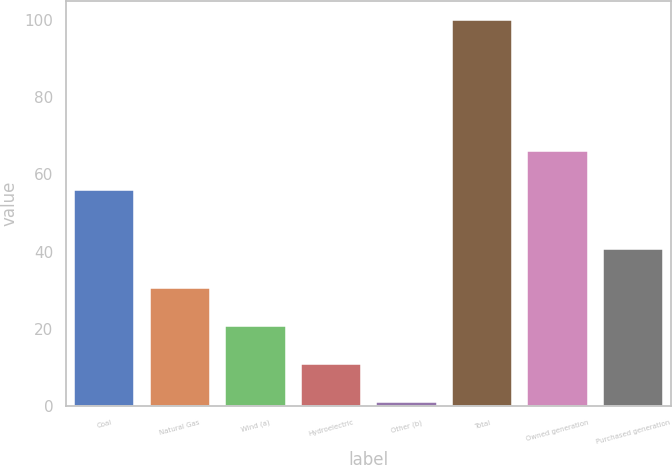Convert chart. <chart><loc_0><loc_0><loc_500><loc_500><bar_chart><fcel>Coal<fcel>Natural Gas<fcel>Wind (a)<fcel>Hydroelectric<fcel>Other (b)<fcel>Total<fcel>Owned generation<fcel>Purchased generation<nl><fcel>56<fcel>30.7<fcel>20.8<fcel>10.9<fcel>1<fcel>100<fcel>66<fcel>40.6<nl></chart> 